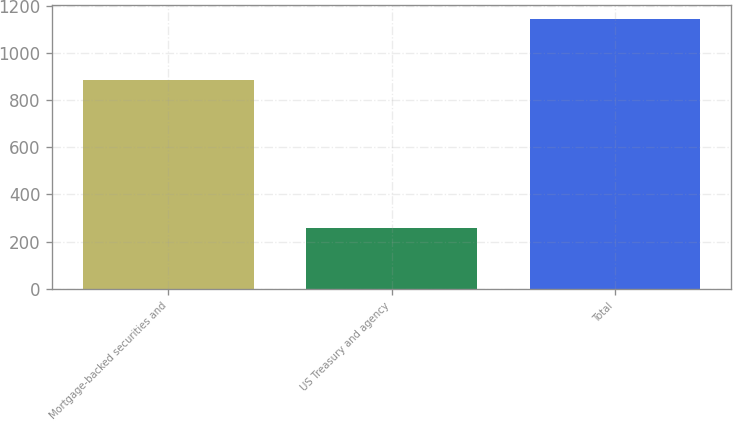Convert chart to OTSL. <chart><loc_0><loc_0><loc_500><loc_500><bar_chart><fcel>Mortgage-backed securities and<fcel>US Treasury and agency<fcel>Total<nl><fcel>886.2<fcel>258.9<fcel>1145.1<nl></chart> 